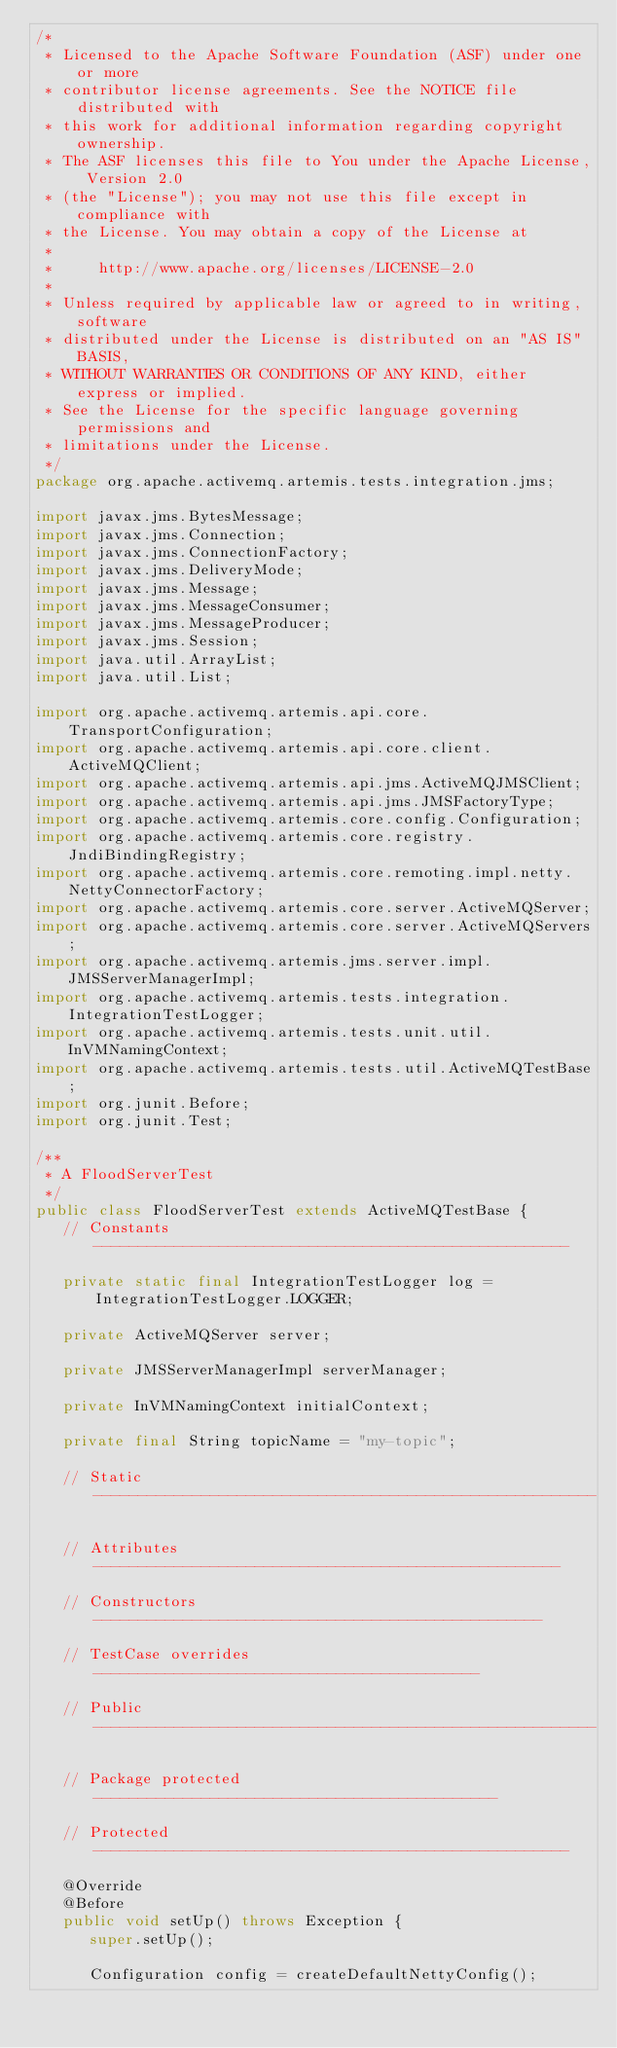Convert code to text. <code><loc_0><loc_0><loc_500><loc_500><_Java_>/*
 * Licensed to the Apache Software Foundation (ASF) under one or more
 * contributor license agreements. See the NOTICE file distributed with
 * this work for additional information regarding copyright ownership.
 * The ASF licenses this file to You under the Apache License, Version 2.0
 * (the "License"); you may not use this file except in compliance with
 * the License. You may obtain a copy of the License at
 *
 *     http://www.apache.org/licenses/LICENSE-2.0
 *
 * Unless required by applicable law or agreed to in writing, software
 * distributed under the License is distributed on an "AS IS" BASIS,
 * WITHOUT WARRANTIES OR CONDITIONS OF ANY KIND, either express or implied.
 * See the License for the specific language governing permissions and
 * limitations under the License.
 */
package org.apache.activemq.artemis.tests.integration.jms;

import javax.jms.BytesMessage;
import javax.jms.Connection;
import javax.jms.ConnectionFactory;
import javax.jms.DeliveryMode;
import javax.jms.Message;
import javax.jms.MessageConsumer;
import javax.jms.MessageProducer;
import javax.jms.Session;
import java.util.ArrayList;
import java.util.List;

import org.apache.activemq.artemis.api.core.TransportConfiguration;
import org.apache.activemq.artemis.api.core.client.ActiveMQClient;
import org.apache.activemq.artemis.api.jms.ActiveMQJMSClient;
import org.apache.activemq.artemis.api.jms.JMSFactoryType;
import org.apache.activemq.artemis.core.config.Configuration;
import org.apache.activemq.artemis.core.registry.JndiBindingRegistry;
import org.apache.activemq.artemis.core.remoting.impl.netty.NettyConnectorFactory;
import org.apache.activemq.artemis.core.server.ActiveMQServer;
import org.apache.activemq.artemis.core.server.ActiveMQServers;
import org.apache.activemq.artemis.jms.server.impl.JMSServerManagerImpl;
import org.apache.activemq.artemis.tests.integration.IntegrationTestLogger;
import org.apache.activemq.artemis.tests.unit.util.InVMNamingContext;
import org.apache.activemq.artemis.tests.util.ActiveMQTestBase;
import org.junit.Before;
import org.junit.Test;

/**
 * A FloodServerTest
 */
public class FloodServerTest extends ActiveMQTestBase {
   // Constants -----------------------------------------------------

   private static final IntegrationTestLogger log = IntegrationTestLogger.LOGGER;

   private ActiveMQServer server;

   private JMSServerManagerImpl serverManager;

   private InVMNamingContext initialContext;

   private final String topicName = "my-topic";

   // Static --------------------------------------------------------

   // Attributes ----------------------------------------------------

   // Constructors --------------------------------------------------

   // TestCase overrides -------------------------------------------

   // Public --------------------------------------------------------

   // Package protected ---------------------------------------------

   // Protected -----------------------------------------------------

   @Override
   @Before
   public void setUp() throws Exception {
      super.setUp();

      Configuration config = createDefaultNettyConfig();</code> 